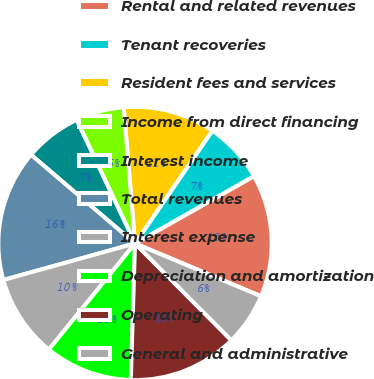<chart> <loc_0><loc_0><loc_500><loc_500><pie_chart><fcel>Rental and related revenues<fcel>Tenant recoveries<fcel>Resident fees and services<fcel>Income from direct financing<fcel>Interest income<fcel>Total revenues<fcel>Interest expense<fcel>Depreciation and amortization<fcel>Operating<fcel>General and administrative<nl><fcel>14.51%<fcel>7.25%<fcel>10.88%<fcel>5.7%<fcel>6.74%<fcel>15.54%<fcel>9.84%<fcel>10.36%<fcel>12.95%<fcel>6.22%<nl></chart> 